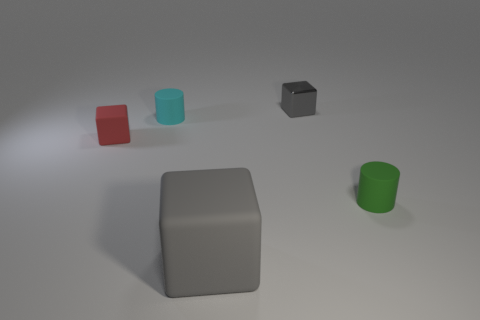Is there anything else that is made of the same material as the tiny gray thing?
Your answer should be compact. No. Are there an equal number of small cyan objects that are to the left of the red matte block and shiny objects?
Ensure brevity in your answer.  No. Is the size of the cylinder on the left side of the gray shiny cube the same as the red thing?
Your answer should be very brief. Yes. How many cyan matte cylinders are there?
Give a very brief answer. 1. What number of blocks are to the left of the tiny gray metallic object and to the right of the cyan cylinder?
Provide a short and direct response. 1. Are there any other large blocks made of the same material as the red cube?
Keep it short and to the point. Yes. What material is the gray object on the left side of the gray block that is behind the large block?
Ensure brevity in your answer.  Rubber. Is the number of shiny cubes that are in front of the cyan matte thing the same as the number of matte blocks that are in front of the big gray thing?
Make the answer very short. Yes. Does the tiny cyan matte thing have the same shape as the gray metal object?
Keep it short and to the point. No. What material is the tiny object that is both to the left of the gray metallic cube and in front of the small cyan cylinder?
Make the answer very short. Rubber. 